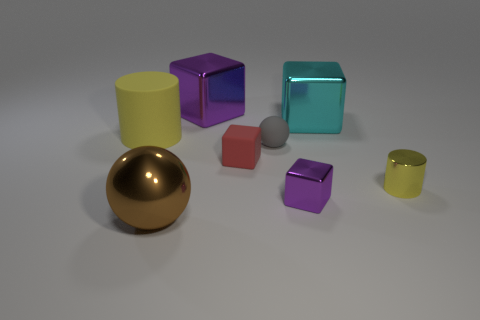Add 1 yellow objects. How many objects exist? 9 Subtract all spheres. How many objects are left? 6 Add 6 big objects. How many big objects are left? 10 Add 3 large cyan shiny cubes. How many large cyan shiny cubes exist? 4 Subtract 0 brown blocks. How many objects are left? 8 Subtract all yellow shiny cylinders. Subtract all cubes. How many objects are left? 3 